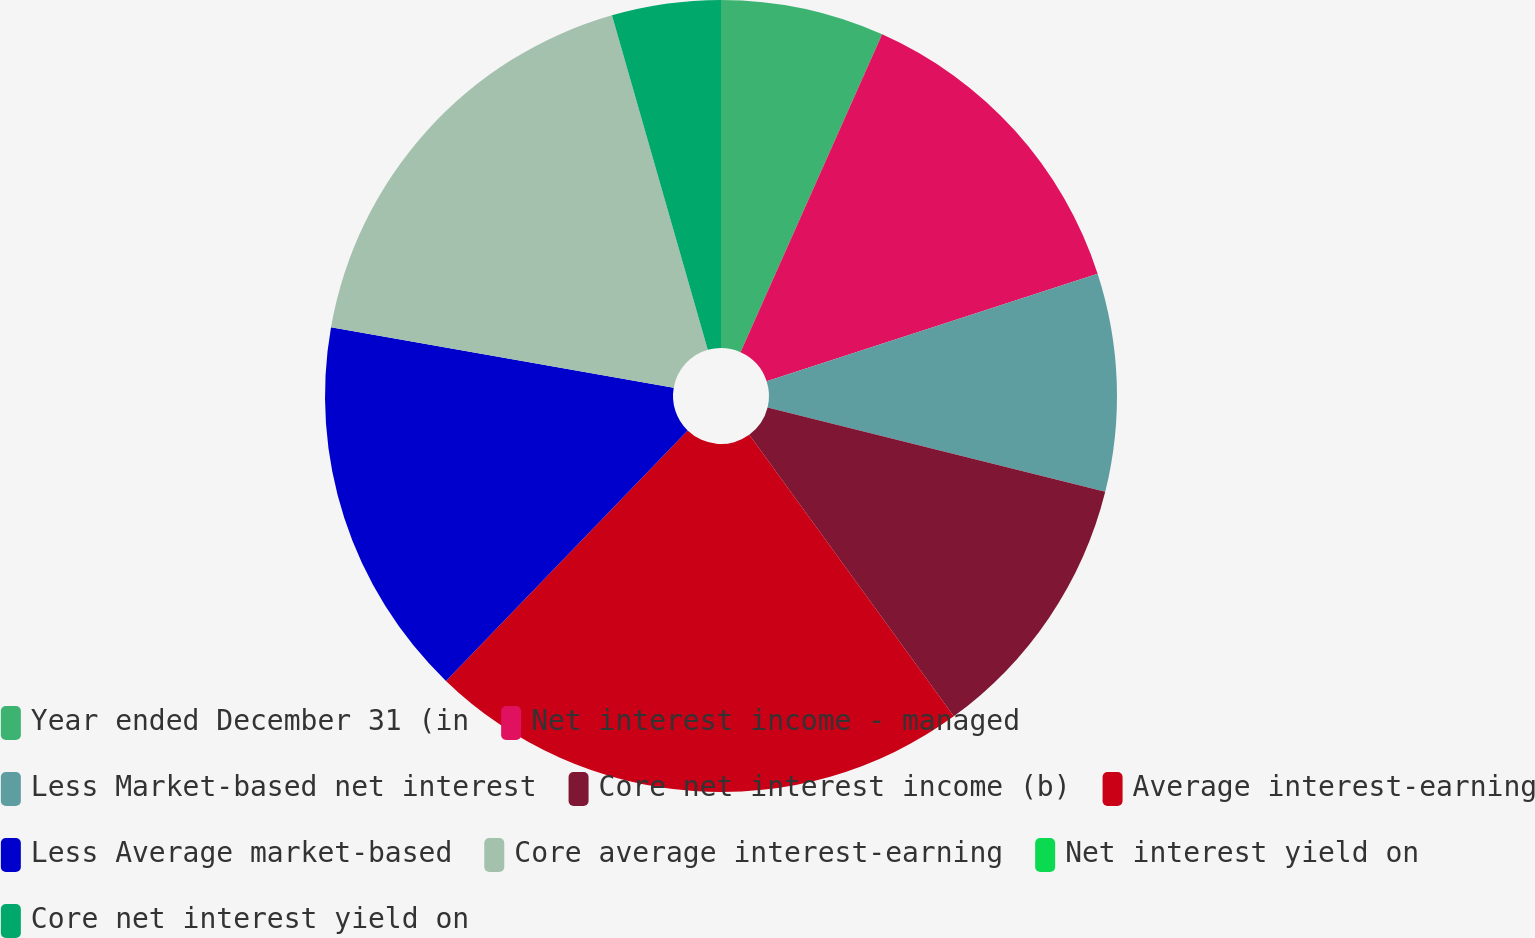Convert chart to OTSL. <chart><loc_0><loc_0><loc_500><loc_500><pie_chart><fcel>Year ended December 31 (in<fcel>Net interest income - managed<fcel>Less Market-based net interest<fcel>Core net interest income (b)<fcel>Average interest-earning<fcel>Less Average market-based<fcel>Core average interest-earning<fcel>Net interest yield on<fcel>Core net interest yield on<nl><fcel>6.67%<fcel>13.33%<fcel>8.89%<fcel>11.11%<fcel>22.22%<fcel>15.56%<fcel>17.78%<fcel>0.0%<fcel>4.44%<nl></chart> 